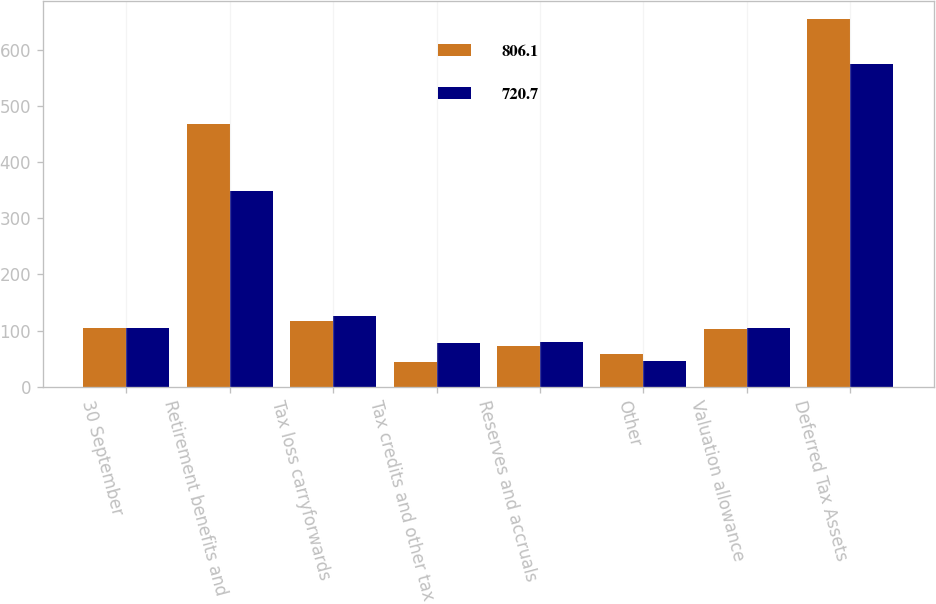Convert chart to OTSL. <chart><loc_0><loc_0><loc_500><loc_500><stacked_bar_chart><ecel><fcel>30 September<fcel>Retirement benefits and<fcel>Tax loss carryforwards<fcel>Tax credits and other tax<fcel>Reserves and accruals<fcel>Other<fcel>Valuation allowance<fcel>Deferred Tax Assets<nl><fcel>806.1<fcel>103.7<fcel>468.7<fcel>116.7<fcel>43.8<fcel>71.9<fcel>57.3<fcel>103.6<fcel>654.8<nl><fcel>720.7<fcel>103.7<fcel>348.9<fcel>125<fcel>78.1<fcel>80.1<fcel>46.1<fcel>103.8<fcel>574.4<nl></chart> 